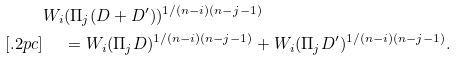<formula> <loc_0><loc_0><loc_500><loc_500>& W _ { i } ( \Pi _ { j } ( D + D ^ { \prime } ) ) ^ { 1 / ( n - i ) ( n - j - 1 ) } \\ [ . 2 p c ] & \quad \ = W _ { i } ( \Pi _ { j } D ) ^ { 1 / ( n - i ) ( n - j - 1 ) } + W _ { i } ( \Pi _ { j } D ^ { \prime } ) ^ { 1 / ( n - i ) ( n - j - 1 ) } .</formula> 